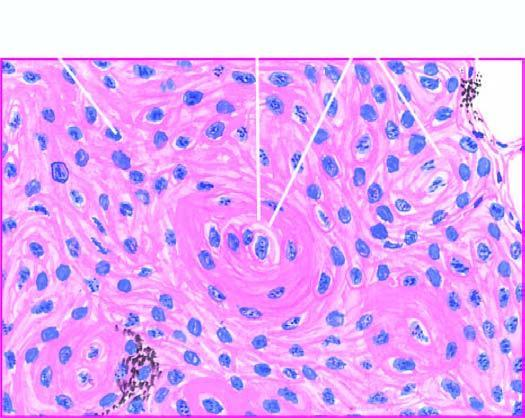what are evident?
Answer the question using a single word or phrase. A few well-developed cell nests 